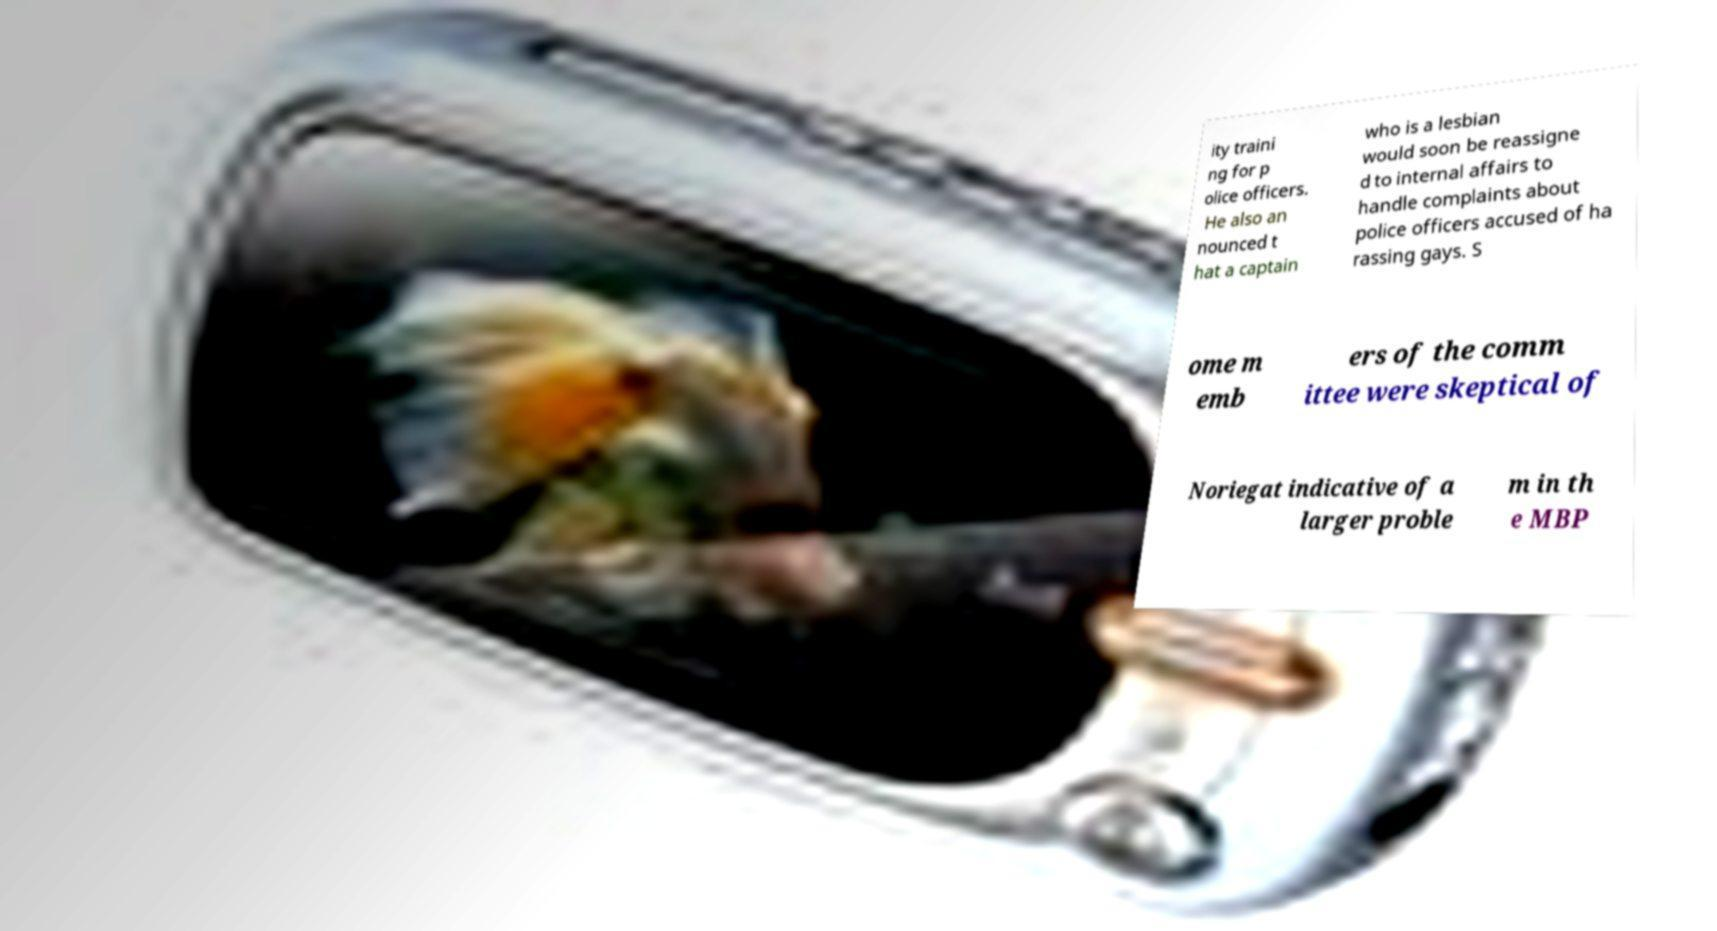Please identify and transcribe the text found in this image. ity traini ng for p olice officers. He also an nounced t hat a captain who is a lesbian would soon be reassigne d to internal affairs to handle complaints about police officers accused of ha rassing gays. S ome m emb ers of the comm ittee were skeptical of Noriegat indicative of a larger proble m in th e MBP 